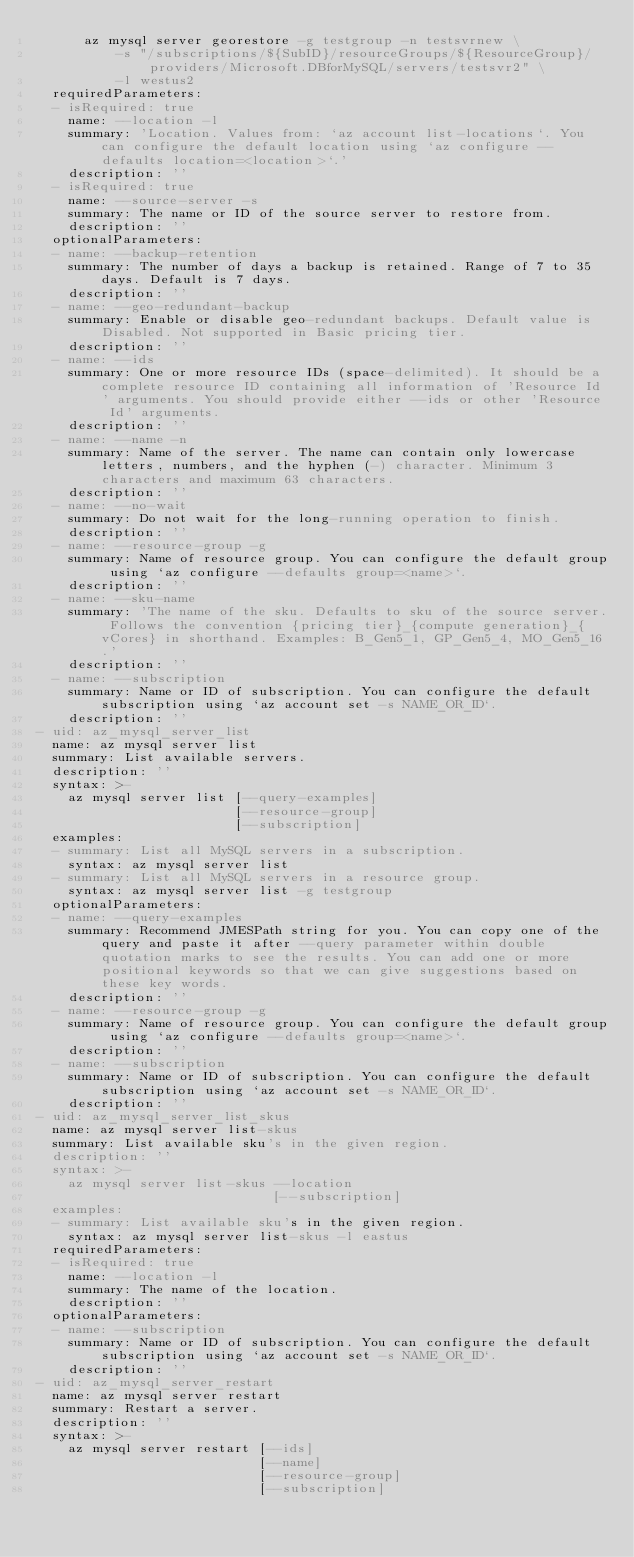Convert code to text. <code><loc_0><loc_0><loc_500><loc_500><_YAML_>      az mysql server georestore -g testgroup -n testsvrnew \
          -s "/subscriptions/${SubID}/resourceGroups/${ResourceGroup}/providers/Microsoft.DBforMySQL/servers/testsvr2" \
          -l westus2
  requiredParameters:
  - isRequired: true
    name: --location -l
    summary: 'Location. Values from: `az account list-locations`. You can configure the default location using `az configure --defaults location=<location>`.'
    description: ''
  - isRequired: true
    name: --source-server -s
    summary: The name or ID of the source server to restore from.
    description: ''
  optionalParameters:
  - name: --backup-retention
    summary: The number of days a backup is retained. Range of 7 to 35 days. Default is 7 days.
    description: ''
  - name: --geo-redundant-backup
    summary: Enable or disable geo-redundant backups. Default value is Disabled. Not supported in Basic pricing tier.
    description: ''
  - name: --ids
    summary: One or more resource IDs (space-delimited). It should be a complete resource ID containing all information of 'Resource Id' arguments. You should provide either --ids or other 'Resource Id' arguments.
    description: ''
  - name: --name -n
    summary: Name of the server. The name can contain only lowercase letters, numbers, and the hyphen (-) character. Minimum 3 characters and maximum 63 characters.
    description: ''
  - name: --no-wait
    summary: Do not wait for the long-running operation to finish.
    description: ''
  - name: --resource-group -g
    summary: Name of resource group. You can configure the default group using `az configure --defaults group=<name>`.
    description: ''
  - name: --sku-name
    summary: 'The name of the sku. Defaults to sku of the source server. Follows the convention {pricing tier}_{compute generation}_{vCores} in shorthand. Examples: B_Gen5_1, GP_Gen5_4, MO_Gen5_16.'
    description: ''
  - name: --subscription
    summary: Name or ID of subscription. You can configure the default subscription using `az account set -s NAME_OR_ID`.
    description: ''
- uid: az_mysql_server_list
  name: az mysql server list
  summary: List available servers.
  description: ''
  syntax: >-
    az mysql server list [--query-examples]
                         [--resource-group]
                         [--subscription]
  examples:
  - summary: List all MySQL servers in a subscription.
    syntax: az mysql server list
  - summary: List all MySQL servers in a resource group.
    syntax: az mysql server list -g testgroup
  optionalParameters:
  - name: --query-examples
    summary: Recommend JMESPath string for you. You can copy one of the query and paste it after --query parameter within double quotation marks to see the results. You can add one or more positional keywords so that we can give suggestions based on these key words.
    description: ''
  - name: --resource-group -g
    summary: Name of resource group. You can configure the default group using `az configure --defaults group=<name>`.
    description: ''
  - name: --subscription
    summary: Name or ID of subscription. You can configure the default subscription using `az account set -s NAME_OR_ID`.
    description: ''
- uid: az_mysql_server_list_skus
  name: az mysql server list-skus
  summary: List available sku's in the given region.
  description: ''
  syntax: >-
    az mysql server list-skus --location
                              [--subscription]
  examples:
  - summary: List available sku's in the given region.
    syntax: az mysql server list-skus -l eastus
  requiredParameters:
  - isRequired: true
    name: --location -l
    summary: The name of the location.
    description: ''
  optionalParameters:
  - name: --subscription
    summary: Name or ID of subscription. You can configure the default subscription using `az account set -s NAME_OR_ID`.
    description: ''
- uid: az_mysql_server_restart
  name: az mysql server restart
  summary: Restart a server.
  description: ''
  syntax: >-
    az mysql server restart [--ids]
                            [--name]
                            [--resource-group]
                            [--subscription]</code> 